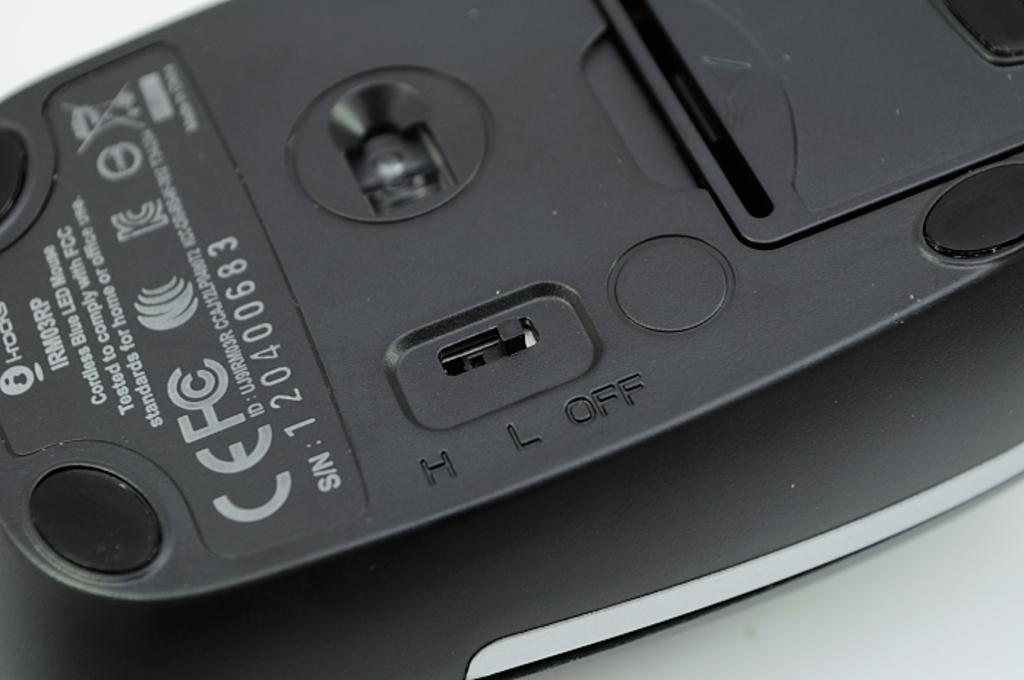<image>
Summarize the visual content of the image. Back of black computer mouse s/n 1 20400683. 